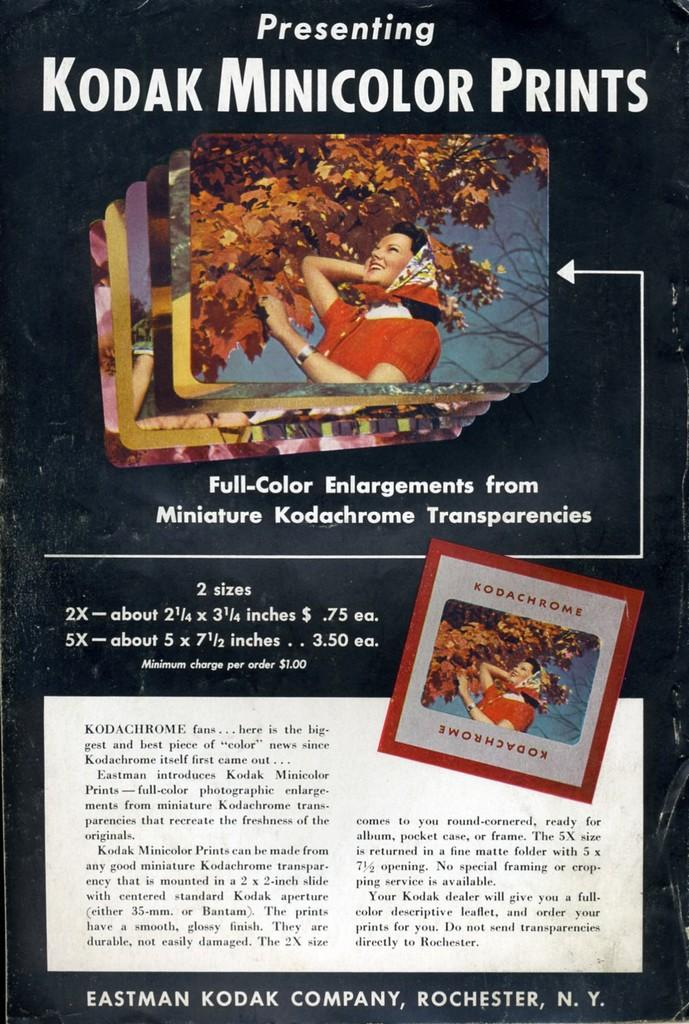What is the main object in the image? There is a flyer in the image. What can be found on the flyer? The flyer contains pictures and text. What type of scarecrow is depicted in the flyer? There is no scarecrow present in the image or mentioned in the provided facts. 